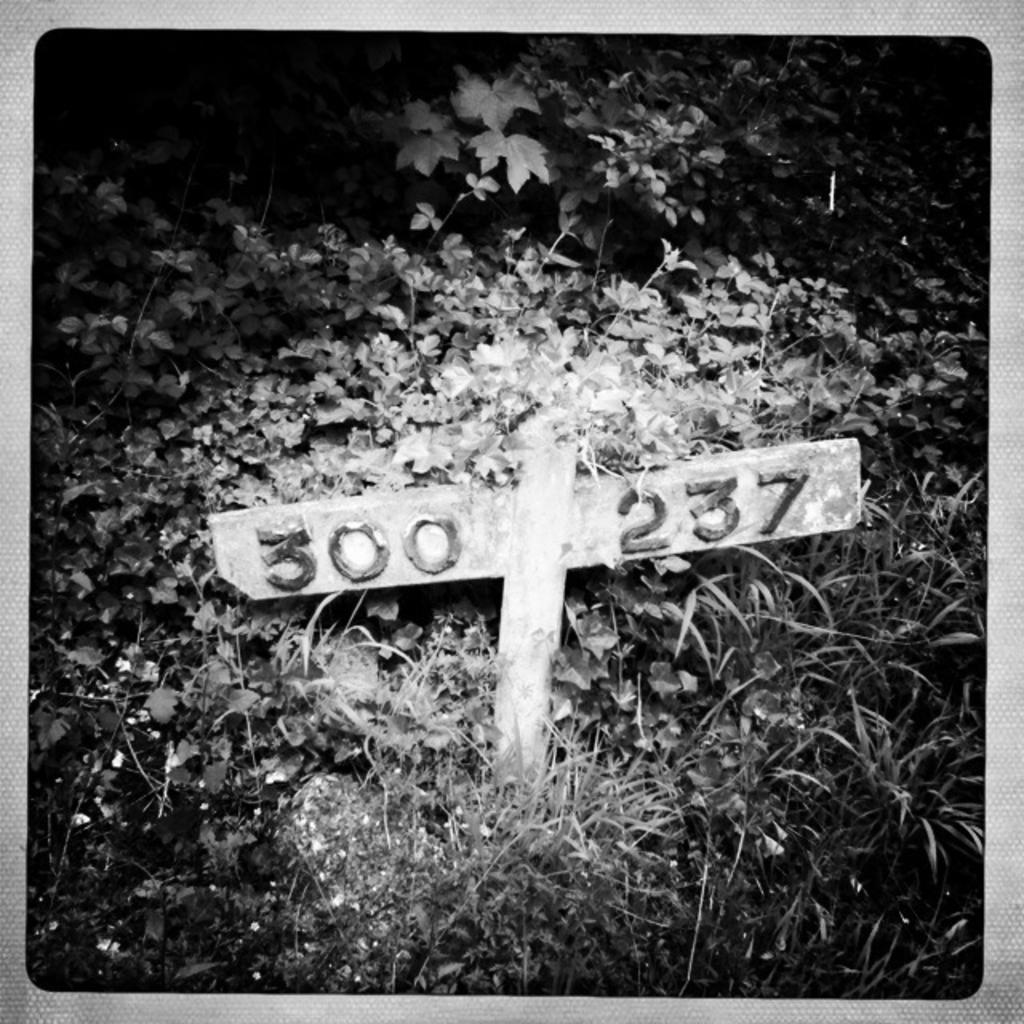<image>
Offer a succinct explanation of the picture presented. A signpost with the numbers 300 and 237. 